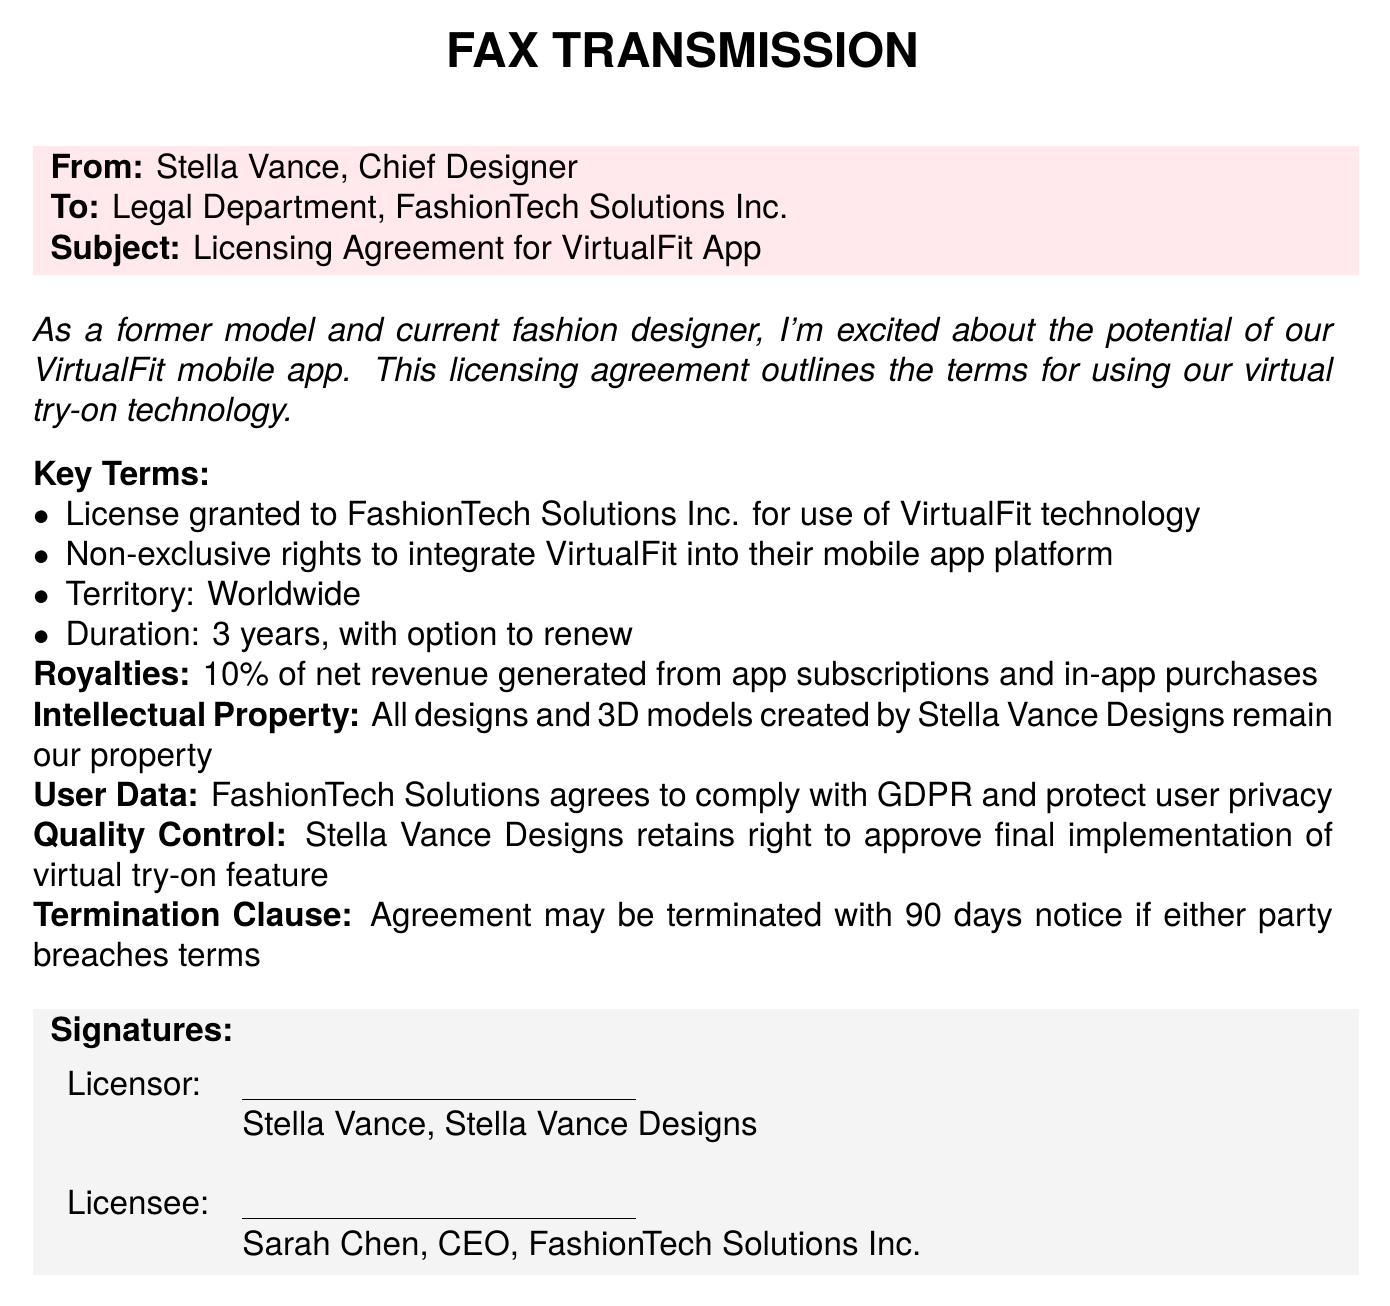What is the subject of the fax? The subject is clearly stated at the beginning of the fax.
Answer: Licensing Agreement for VirtualFit App Who is the sender of the fax? The sender's name is listed in the "From" section of the fax.
Answer: Stella Vance What is the licensing duration specified in the agreement? The fax explicitly states the duration of the license.
Answer: 3 years What are the royalties percentage mentioned? The royalties section specifies a percentage of net revenue.
Answer: 10% What does the territory for the license cover? The territory is defined in one of the key terms mentioned.
Answer: Worldwide Who retains the intellectual property rights? The document specifies the holder of the intellectual property rights.
Answer: Stella Vance Designs What is required for app termination notice? The document states the conditions under which the agreement can be terminated.
Answer: 90 days notice Who is the licensee in the agreement? The fax provides the name of the licensee in the signature section.
Answer: Sarah Chen What user data compliance does FashionTech Solutions agree to? The relevance of the compliance guidelines is stated within the user data section.
Answer: GDPR 